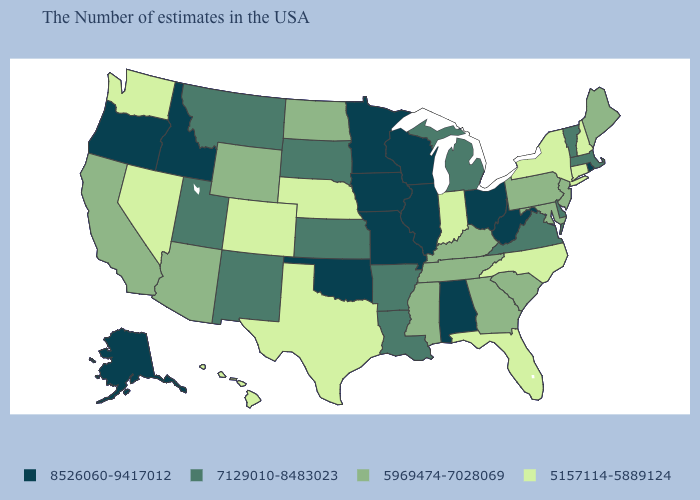Among the states that border Colorado , does Oklahoma have the highest value?
Keep it brief. Yes. What is the value of Montana?
Answer briefly. 7129010-8483023. Name the states that have a value in the range 5157114-5889124?
Quick response, please. New Hampshire, Connecticut, New York, North Carolina, Florida, Indiana, Nebraska, Texas, Colorado, Nevada, Washington, Hawaii. Name the states that have a value in the range 7129010-8483023?
Answer briefly. Massachusetts, Vermont, Delaware, Virginia, Michigan, Louisiana, Arkansas, Kansas, South Dakota, New Mexico, Utah, Montana. Does South Dakota have the highest value in the MidWest?
Concise answer only. No. Does the map have missing data?
Answer briefly. No. What is the value of Mississippi?
Be succinct. 5969474-7028069. Among the states that border Ohio , does Indiana have the lowest value?
Short answer required. Yes. What is the value of New Hampshire?
Quick response, please. 5157114-5889124. What is the value of Wisconsin?
Concise answer only. 8526060-9417012. What is the highest value in states that border North Carolina?
Answer briefly. 7129010-8483023. Name the states that have a value in the range 7129010-8483023?
Be succinct. Massachusetts, Vermont, Delaware, Virginia, Michigan, Louisiana, Arkansas, Kansas, South Dakota, New Mexico, Utah, Montana. How many symbols are there in the legend?
Keep it brief. 4. What is the value of Maine?
Quick response, please. 5969474-7028069. 